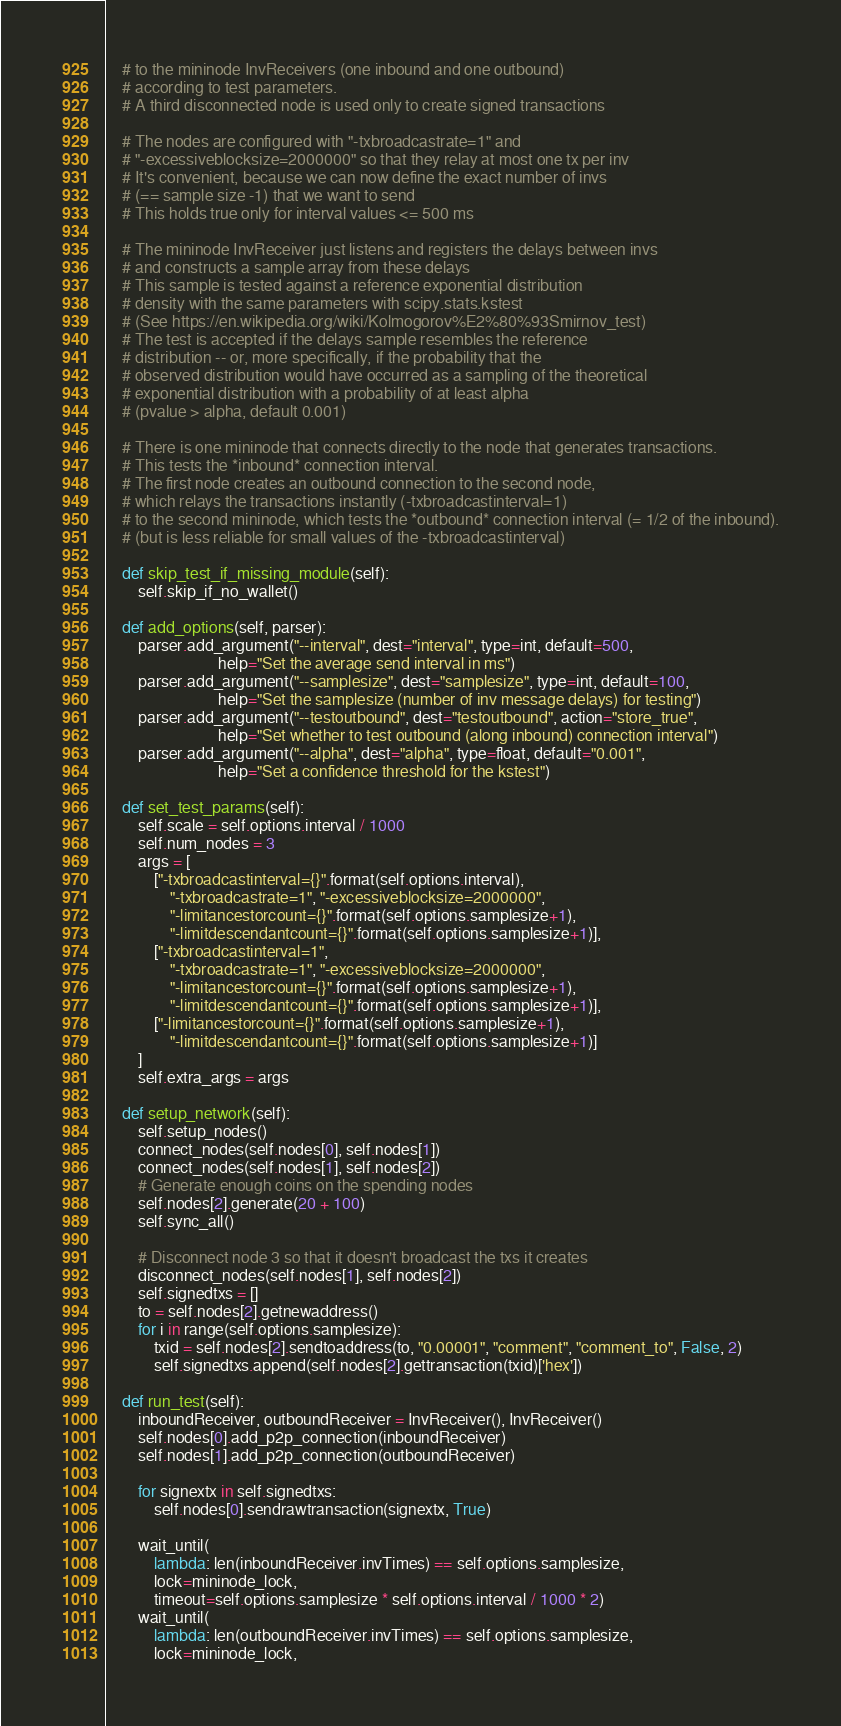<code> <loc_0><loc_0><loc_500><loc_500><_Python_>    # to the mininode InvReceivers (one inbound and one outbound)
    # according to test parameters.
    # A third disconnected node is used only to create signed transactions

    # The nodes are configured with "-txbroadcastrate=1" and
    # "-excessiveblocksize=2000000" so that they relay at most one tx per inv
    # It's convenient, because we can now define the exact number of invs
    # (== sample size -1) that we want to send
    # This holds true only for interval values <= 500 ms

    # The mininode InvReceiver just listens and registers the delays between invs
    # and constructs a sample array from these delays
    # This sample is tested against a reference exponential distribution
    # density with the same parameters with scipy.stats.kstest
    # (See https://en.wikipedia.org/wiki/Kolmogorov%E2%80%93Smirnov_test)
    # The test is accepted if the delays sample resembles the reference
    # distribution -- or, more specifically, if the probability that the
    # observed distribution would have occurred as a sampling of the theoretical
    # exponential distribution with a probability of at least alpha
    # (pvalue > alpha, default 0.001)

    # There is one mininode that connects directly to the node that generates transactions.
    # This tests the *inbound* connection interval.
    # The first node creates an outbound connection to the second node,
    # which relays the transactions instantly (-txbroadcastinterval=1)
    # to the second mininode, which tests the *outbound* connection interval (= 1/2 of the inbound).
    # (but is less reliable for small values of the -txbroadcastinterval)

    def skip_test_if_missing_module(self):
        self.skip_if_no_wallet()

    def add_options(self, parser):
        parser.add_argument("--interval", dest="interval", type=int, default=500,
                            help="Set the average send interval in ms")
        parser.add_argument("--samplesize", dest="samplesize", type=int, default=100,
                            help="Set the samplesize (number of inv message delays) for testing")
        parser.add_argument("--testoutbound", dest="testoutbound", action="store_true",
                            help="Set whether to test outbound (along inbound) connection interval")
        parser.add_argument("--alpha", dest="alpha", type=float, default="0.001",
                            help="Set a confidence threshold for the kstest")

    def set_test_params(self):
        self.scale = self.options.interval / 1000
        self.num_nodes = 3
        args = [
            ["-txbroadcastinterval={}".format(self.options.interval),
                "-txbroadcastrate=1", "-excessiveblocksize=2000000",
                "-limitancestorcount={}".format(self.options.samplesize+1),
                "-limitdescendantcount={}".format(self.options.samplesize+1)],
            ["-txbroadcastinterval=1",
                "-txbroadcastrate=1", "-excessiveblocksize=2000000",
                "-limitancestorcount={}".format(self.options.samplesize+1),
                "-limitdescendantcount={}".format(self.options.samplesize+1)],
            ["-limitancestorcount={}".format(self.options.samplesize+1),
                "-limitdescendantcount={}".format(self.options.samplesize+1)]
        ]
        self.extra_args = args

    def setup_network(self):
        self.setup_nodes()
        connect_nodes(self.nodes[0], self.nodes[1])
        connect_nodes(self.nodes[1], self.nodes[2])
        # Generate enough coins on the spending nodes
        self.nodes[2].generate(20 + 100)
        self.sync_all()

        # Disconnect node 3 so that it doesn't broadcast the txs it creates
        disconnect_nodes(self.nodes[1], self.nodes[2])
        self.signedtxs = []
        to = self.nodes[2].getnewaddress()
        for i in range(self.options.samplesize):
            txid = self.nodes[2].sendtoaddress(to, "0.00001", "comment", "comment_to", False, 2)
            self.signedtxs.append(self.nodes[2].gettransaction(txid)['hex'])

    def run_test(self):
        inboundReceiver, outboundReceiver = InvReceiver(), InvReceiver()
        self.nodes[0].add_p2p_connection(inboundReceiver)
        self.nodes[1].add_p2p_connection(outboundReceiver)

        for signextx in self.signedtxs:
            self.nodes[0].sendrawtransaction(signextx, True)

        wait_until(
            lambda: len(inboundReceiver.invTimes) == self.options.samplesize,
            lock=mininode_lock,
            timeout=self.options.samplesize * self.options.interval / 1000 * 2)
        wait_until(
            lambda: len(outboundReceiver.invTimes) == self.options.samplesize,
            lock=mininode_lock,</code> 